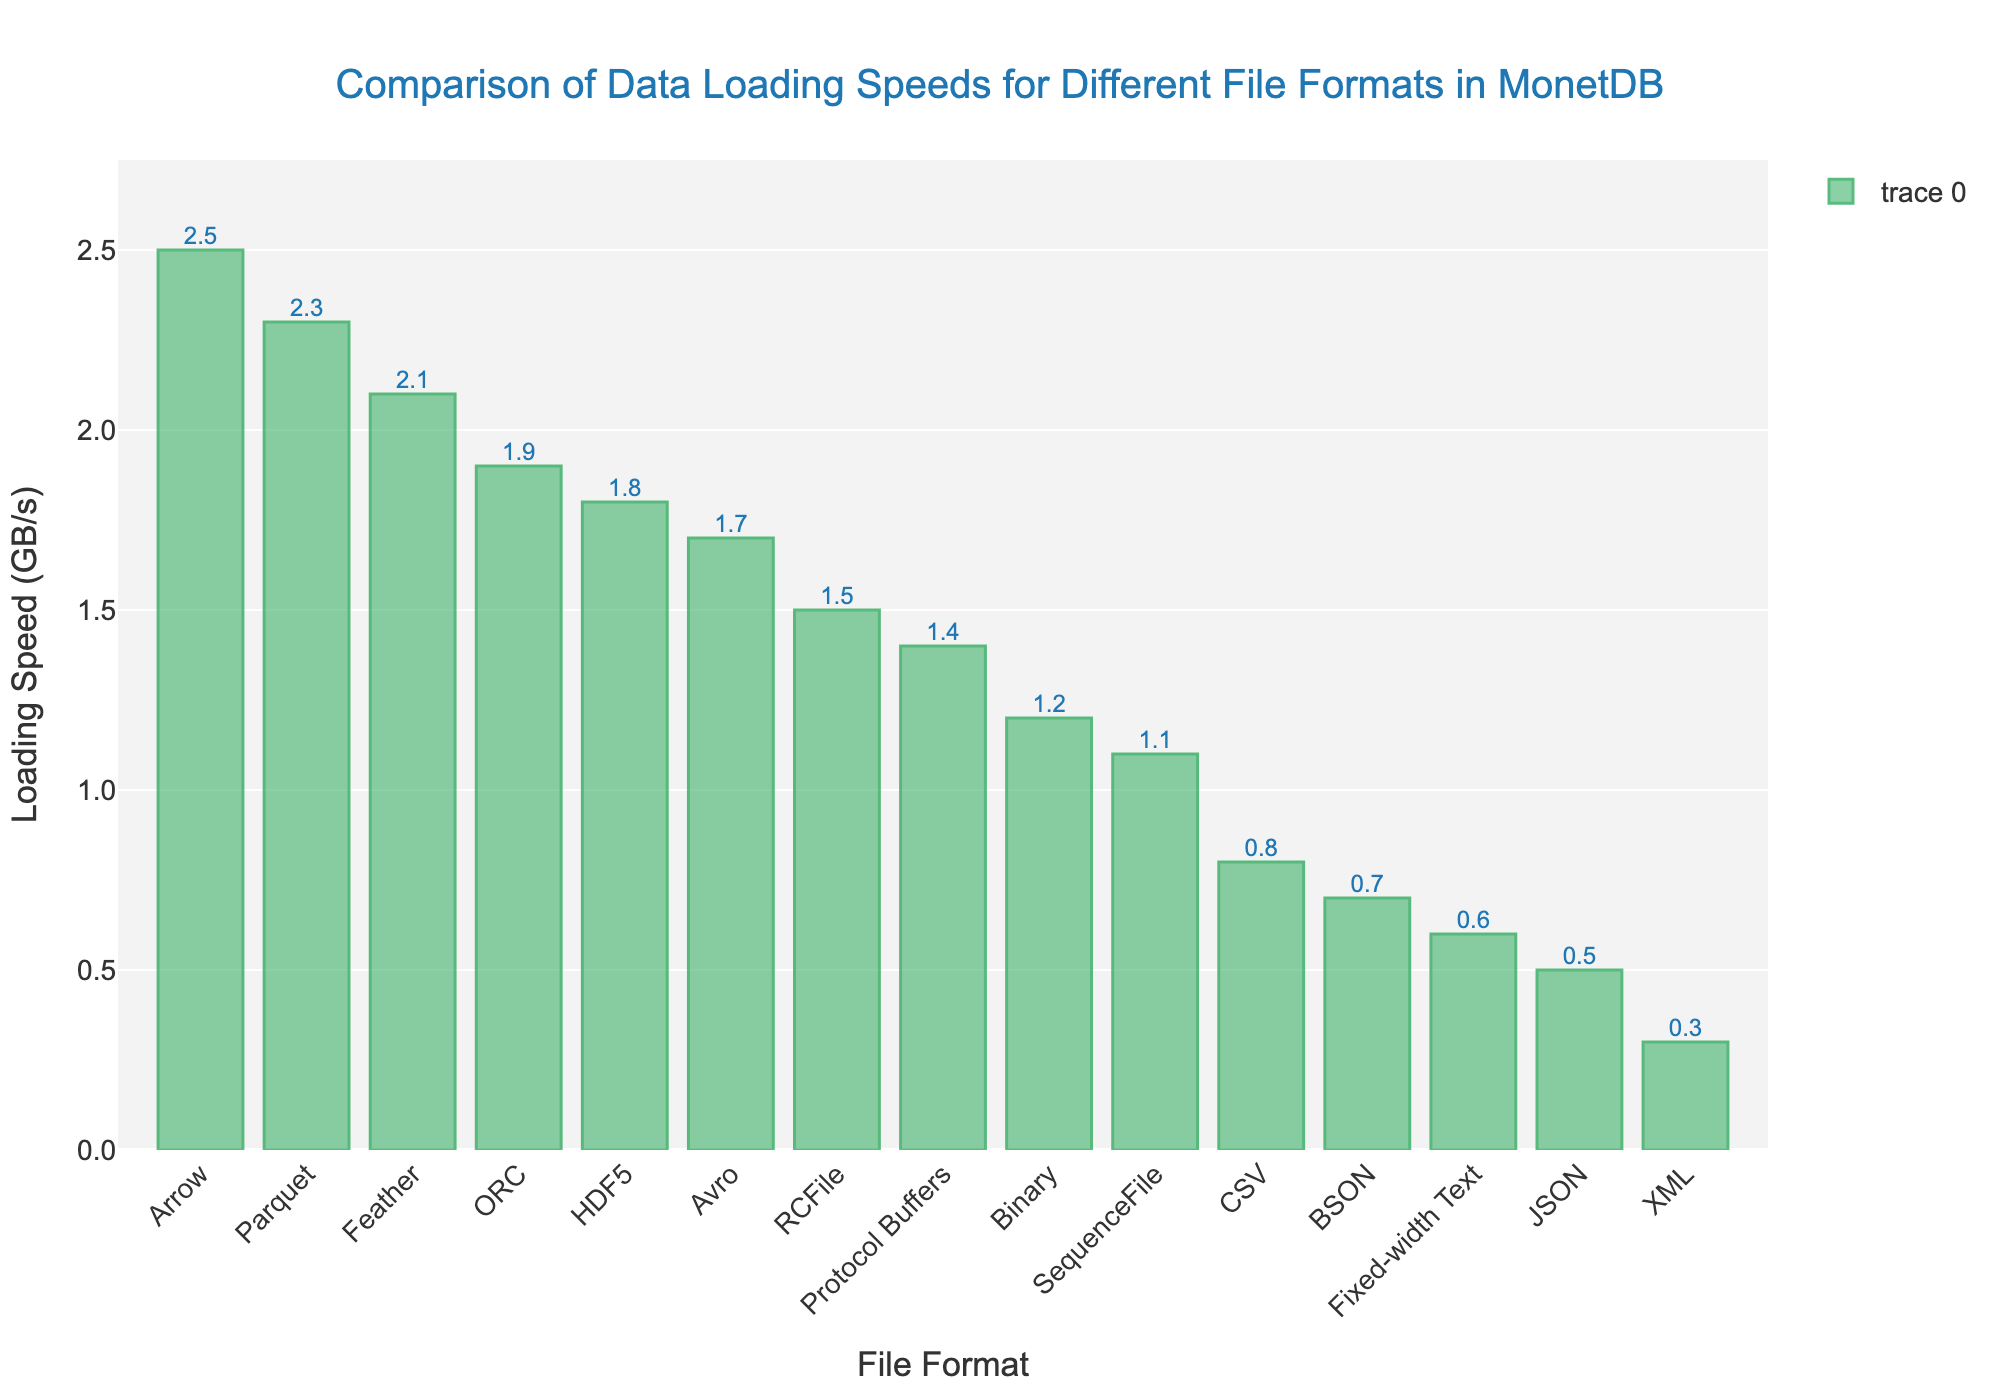Which file format has the highest data loading speed in MonetDB? The highest bar represents the file format with the highest loading speed, which is Arrow at 2.5 GB/s.
Answer: Arrow Which file format has the lowest data loading speed in MonetDB? The smallest bar represents the file format with the lowest loading speed, which is XML at 0.3 GB/s.
Answer: XML What is the difference in loading speed between Arrow and JSON file formats? Arrow has a loading speed of 2.5 GB/s and JSON has a loading speed of 0.5 GB/s. The difference is 2.5 - 0.5 = 2 GB/s.
Answer: 2 GB/s Among CSV, Parquet, and ORC, which file format has the highest loading speed? Parquet has a loading speed of 2.3 GB/s, which is higher than CSV's 0.8 GB/s and ORC's 1.9 GB/s.
Answer: Parquet What is the average loading speed of all file formats? Sum all the loading speeds (0.8 + 2.3 + 1.9 + 0.5 + 1.7 + 2.5 + 1.2 + 0.3 + 0.6 + 1.5 + 1.1 + 2.1 + 1.8 + 0.7 + 1.4) = 20.4 and divide by the number of file formats (15). The average loading speed is 20.4 / 15 = 1.36 GB/s.
Answer: 1.36 GB/s What are the file formats with a loading speed lower than 1 GB/s? The file formats with bars less than 1 GB/s in height are XML (0.3 GB/s), JSON (0.5 GB/s), Fixed-width Text (0.6 GB/s), and BSON (0.7 GB/s).
Answer: XML, JSON, Fixed-width Text, BSON How many file formats have a loading speed higher than 2 GB/s? The file formats with bars higher than 2 GB/s are Parquet (2.3 GB/s), Arrow (2.5 GB/s), and Feather (2.1 GB/s), which counts up to 3 formats.
Answer: 3 What is the sum of loading speeds for Binary and SequenceFile formats? Binary has a loading speed of 1.2 GB/s and SequenceFile has a loading speed of 1.1 GB/s. The sum is 1.2 + 1.1 = 2.3 GB/s.
Answer: 2.3 GB/s How does the loading speed of RCFile compare to Protocol Buffers? RCFile has a loading speed of 1.5 GB/s and Protocol Buffers has a loading speed of 1.4 GB/s. Thus, RCFile is slightly higher by 0.1 GB/s.
Answer: RCFile is higher 